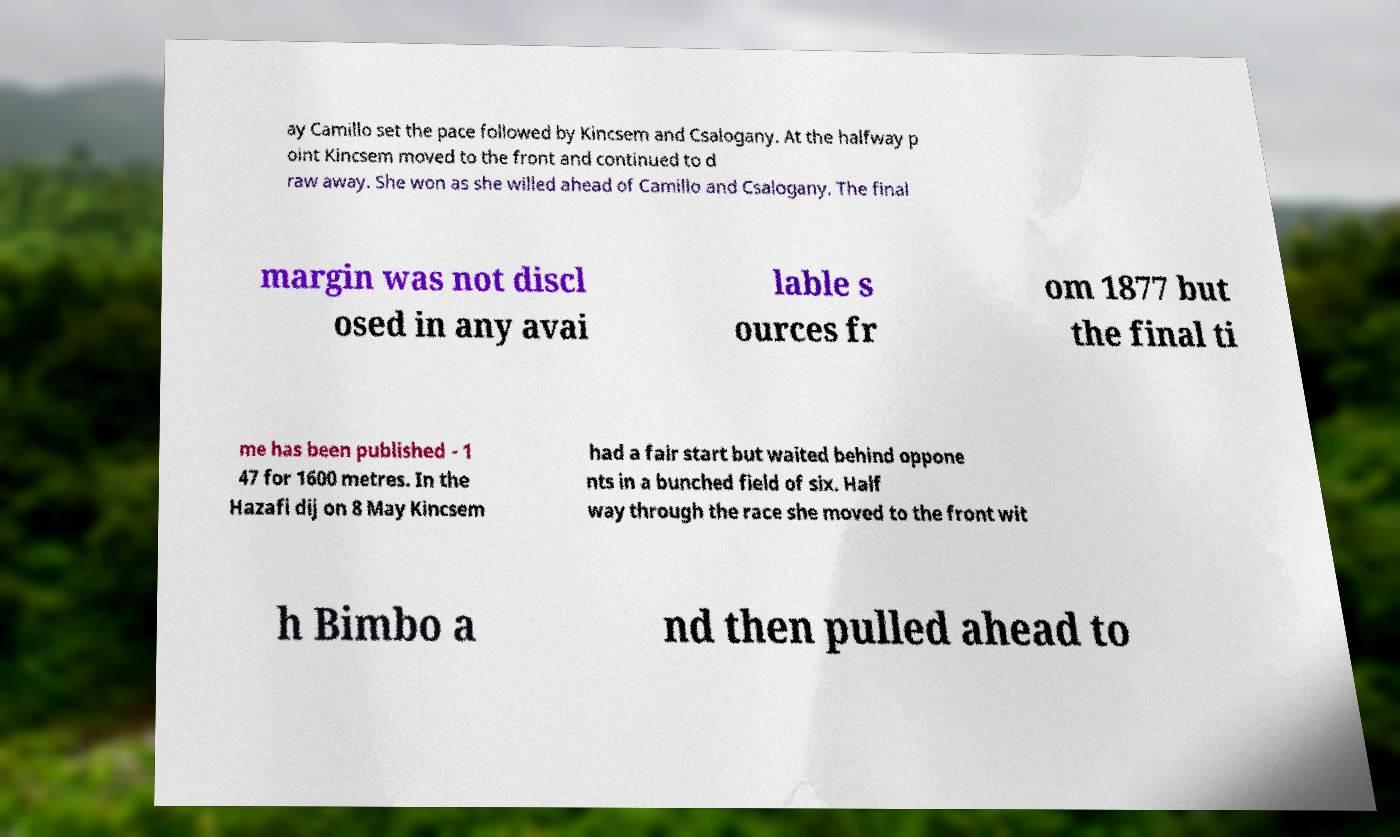Can you accurately transcribe the text from the provided image for me? ay Camillo set the pace followed by Kincsem and Csalogany. At the halfway p oint Kincsem moved to the front and continued to d raw away. She won as she willed ahead of Camillo and Csalogany. The final margin was not discl osed in any avai lable s ources fr om 1877 but the final ti me has been published - 1 47 for 1600 metres. In the Hazafi dij on 8 May Kincsem had a fair start but waited behind oppone nts in a bunched field of six. Half way through the race she moved to the front wit h Bimbo a nd then pulled ahead to 